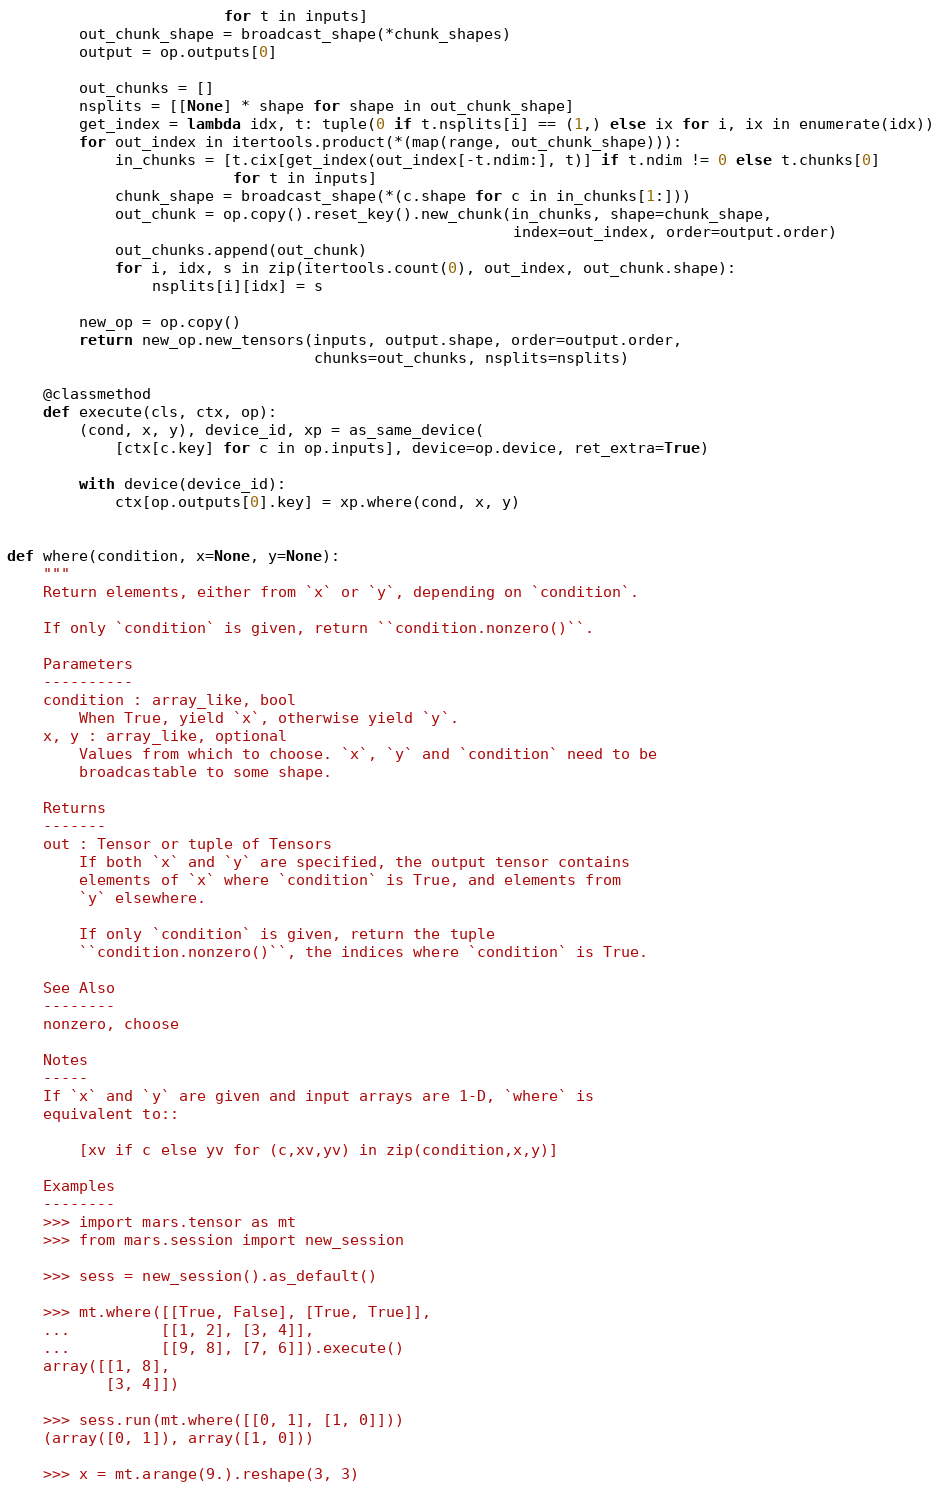Convert code to text. <code><loc_0><loc_0><loc_500><loc_500><_Python_>                        for t in inputs]
        out_chunk_shape = broadcast_shape(*chunk_shapes)
        output = op.outputs[0]

        out_chunks = []
        nsplits = [[None] * shape for shape in out_chunk_shape]
        get_index = lambda idx, t: tuple(0 if t.nsplits[i] == (1,) else ix for i, ix in enumerate(idx))
        for out_index in itertools.product(*(map(range, out_chunk_shape))):
            in_chunks = [t.cix[get_index(out_index[-t.ndim:], t)] if t.ndim != 0 else t.chunks[0]
                         for t in inputs]
            chunk_shape = broadcast_shape(*(c.shape for c in in_chunks[1:]))
            out_chunk = op.copy().reset_key().new_chunk(in_chunks, shape=chunk_shape,
                                                        index=out_index, order=output.order)
            out_chunks.append(out_chunk)
            for i, idx, s in zip(itertools.count(0), out_index, out_chunk.shape):
                nsplits[i][idx] = s

        new_op = op.copy()
        return new_op.new_tensors(inputs, output.shape, order=output.order,
                                  chunks=out_chunks, nsplits=nsplits)

    @classmethod
    def execute(cls, ctx, op):
        (cond, x, y), device_id, xp = as_same_device(
            [ctx[c.key] for c in op.inputs], device=op.device, ret_extra=True)

        with device(device_id):
            ctx[op.outputs[0].key] = xp.where(cond, x, y)


def where(condition, x=None, y=None):
    """
    Return elements, either from `x` or `y`, depending on `condition`.

    If only `condition` is given, return ``condition.nonzero()``.

    Parameters
    ----------
    condition : array_like, bool
        When True, yield `x`, otherwise yield `y`.
    x, y : array_like, optional
        Values from which to choose. `x`, `y` and `condition` need to be
        broadcastable to some shape.

    Returns
    -------
    out : Tensor or tuple of Tensors
        If both `x` and `y` are specified, the output tensor contains
        elements of `x` where `condition` is True, and elements from
        `y` elsewhere.

        If only `condition` is given, return the tuple
        ``condition.nonzero()``, the indices where `condition` is True.

    See Also
    --------
    nonzero, choose

    Notes
    -----
    If `x` and `y` are given and input arrays are 1-D, `where` is
    equivalent to::

        [xv if c else yv for (c,xv,yv) in zip(condition,x,y)]

    Examples
    --------
    >>> import mars.tensor as mt
    >>> from mars.session import new_session

    >>> sess = new_session().as_default()

    >>> mt.where([[True, False], [True, True]],
    ...          [[1, 2], [3, 4]],
    ...          [[9, 8], [7, 6]]).execute()
    array([[1, 8],
           [3, 4]])

    >>> sess.run(mt.where([[0, 1], [1, 0]]))
    (array([0, 1]), array([1, 0]))

    >>> x = mt.arange(9.).reshape(3, 3)</code> 